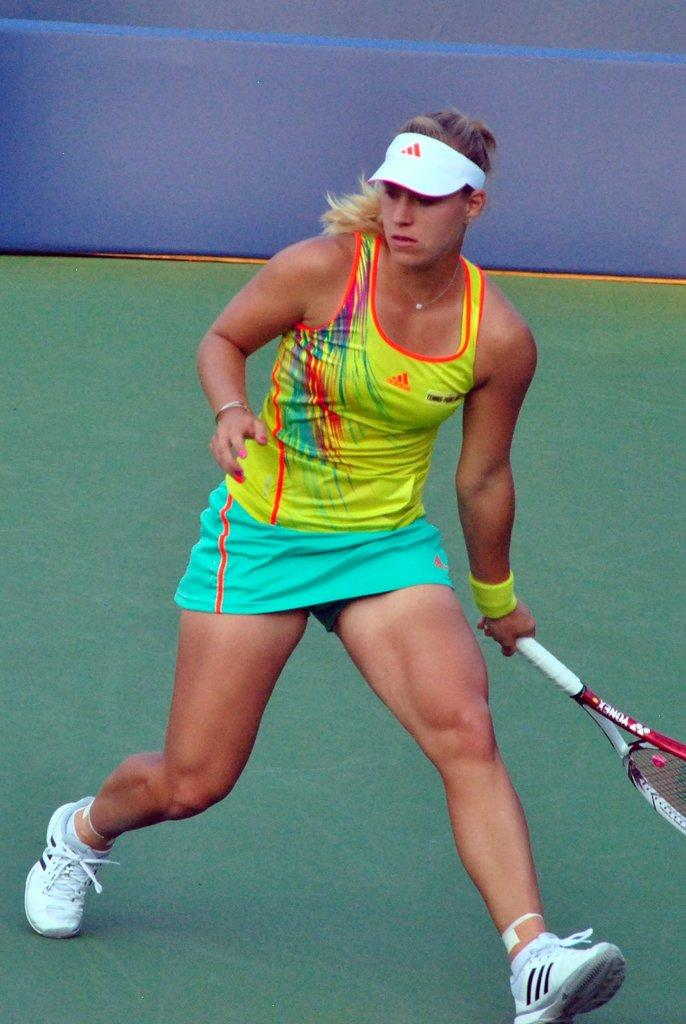Who is the main subject in the image? There is a woman in the image. What is the woman holding in the image? The woman is holding a tennis racket. What activity is the woman likely engaged in? The woman is likely playing tennis. What is the color of the background in the image? The background of the image appears to be blue. What is the woman wearing in the image? The woman is wearing a green dress and white shoes. Is the woman playing tennis during a rainstorm in the image? There is no indication of a rainstorm in the image; the background appears to be blue, and the woman is holding a tennis racket. Can you see a bed in the image? There is no bed present in the image; it features a woman holding a tennis racket. 